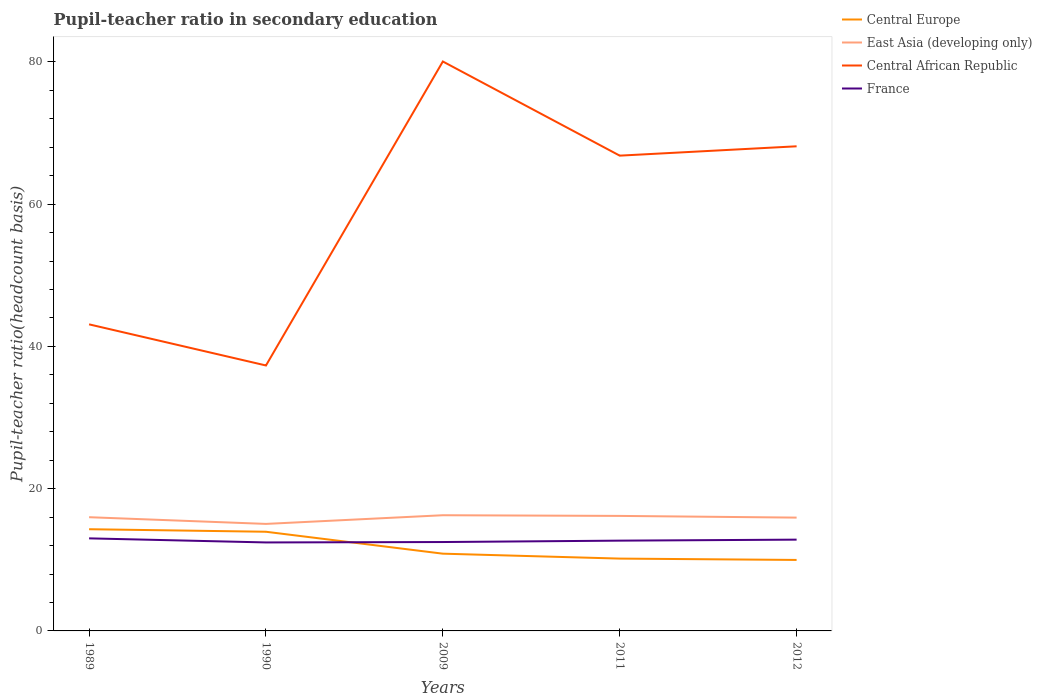How many different coloured lines are there?
Provide a succinct answer. 4. Does the line corresponding to Central Europe intersect with the line corresponding to Central African Republic?
Provide a short and direct response. No. Is the number of lines equal to the number of legend labels?
Provide a short and direct response. Yes. Across all years, what is the maximum pupil-teacher ratio in secondary education in Central Europe?
Ensure brevity in your answer.  9.98. What is the total pupil-teacher ratio in secondary education in Central Europe in the graph?
Your answer should be compact. 3.77. What is the difference between the highest and the second highest pupil-teacher ratio in secondary education in France?
Keep it short and to the point. 0.57. What is the difference between the highest and the lowest pupil-teacher ratio in secondary education in Central African Republic?
Your answer should be compact. 3. Is the pupil-teacher ratio in secondary education in Central African Republic strictly greater than the pupil-teacher ratio in secondary education in Central Europe over the years?
Offer a very short reply. No. How many lines are there?
Keep it short and to the point. 4. What is the difference between two consecutive major ticks on the Y-axis?
Offer a terse response. 20. Are the values on the major ticks of Y-axis written in scientific E-notation?
Your answer should be very brief. No. Does the graph contain grids?
Provide a succinct answer. No. Where does the legend appear in the graph?
Provide a succinct answer. Top right. What is the title of the graph?
Your answer should be very brief. Pupil-teacher ratio in secondary education. Does "Comoros" appear as one of the legend labels in the graph?
Provide a succinct answer. No. What is the label or title of the Y-axis?
Give a very brief answer. Pupil-teacher ratio(headcount basis). What is the Pupil-teacher ratio(headcount basis) of Central Europe in 1989?
Ensure brevity in your answer.  14.3. What is the Pupil-teacher ratio(headcount basis) of East Asia (developing only) in 1989?
Make the answer very short. 15.99. What is the Pupil-teacher ratio(headcount basis) of Central African Republic in 1989?
Provide a short and direct response. 43.1. What is the Pupil-teacher ratio(headcount basis) of France in 1989?
Your response must be concise. 13.01. What is the Pupil-teacher ratio(headcount basis) in Central Europe in 1990?
Provide a succinct answer. 13.94. What is the Pupil-teacher ratio(headcount basis) in East Asia (developing only) in 1990?
Offer a terse response. 15.04. What is the Pupil-teacher ratio(headcount basis) of Central African Republic in 1990?
Give a very brief answer. 37.32. What is the Pupil-teacher ratio(headcount basis) in France in 1990?
Give a very brief answer. 12.44. What is the Pupil-teacher ratio(headcount basis) of Central Europe in 2009?
Provide a succinct answer. 10.86. What is the Pupil-teacher ratio(headcount basis) of East Asia (developing only) in 2009?
Ensure brevity in your answer.  16.26. What is the Pupil-teacher ratio(headcount basis) in Central African Republic in 2009?
Your response must be concise. 80.05. What is the Pupil-teacher ratio(headcount basis) of France in 2009?
Keep it short and to the point. 12.5. What is the Pupil-teacher ratio(headcount basis) in Central Europe in 2011?
Your answer should be very brief. 10.17. What is the Pupil-teacher ratio(headcount basis) in East Asia (developing only) in 2011?
Offer a very short reply. 16.17. What is the Pupil-teacher ratio(headcount basis) in Central African Republic in 2011?
Keep it short and to the point. 66.82. What is the Pupil-teacher ratio(headcount basis) of France in 2011?
Provide a succinct answer. 12.69. What is the Pupil-teacher ratio(headcount basis) of Central Europe in 2012?
Make the answer very short. 9.98. What is the Pupil-teacher ratio(headcount basis) of East Asia (developing only) in 2012?
Provide a succinct answer. 15.93. What is the Pupil-teacher ratio(headcount basis) of Central African Republic in 2012?
Give a very brief answer. 68.13. What is the Pupil-teacher ratio(headcount basis) in France in 2012?
Ensure brevity in your answer.  12.83. Across all years, what is the maximum Pupil-teacher ratio(headcount basis) in Central Europe?
Your response must be concise. 14.3. Across all years, what is the maximum Pupil-teacher ratio(headcount basis) in East Asia (developing only)?
Your answer should be very brief. 16.26. Across all years, what is the maximum Pupil-teacher ratio(headcount basis) in Central African Republic?
Provide a succinct answer. 80.05. Across all years, what is the maximum Pupil-teacher ratio(headcount basis) in France?
Ensure brevity in your answer.  13.01. Across all years, what is the minimum Pupil-teacher ratio(headcount basis) of Central Europe?
Offer a very short reply. 9.98. Across all years, what is the minimum Pupil-teacher ratio(headcount basis) of East Asia (developing only)?
Your answer should be compact. 15.04. Across all years, what is the minimum Pupil-teacher ratio(headcount basis) of Central African Republic?
Your answer should be compact. 37.32. Across all years, what is the minimum Pupil-teacher ratio(headcount basis) of France?
Offer a very short reply. 12.44. What is the total Pupil-teacher ratio(headcount basis) in Central Europe in the graph?
Offer a terse response. 59.24. What is the total Pupil-teacher ratio(headcount basis) in East Asia (developing only) in the graph?
Keep it short and to the point. 79.39. What is the total Pupil-teacher ratio(headcount basis) in Central African Republic in the graph?
Make the answer very short. 295.42. What is the total Pupil-teacher ratio(headcount basis) of France in the graph?
Provide a short and direct response. 63.47. What is the difference between the Pupil-teacher ratio(headcount basis) in Central Europe in 1989 and that in 1990?
Offer a very short reply. 0.36. What is the difference between the Pupil-teacher ratio(headcount basis) in East Asia (developing only) in 1989 and that in 1990?
Your answer should be very brief. 0.94. What is the difference between the Pupil-teacher ratio(headcount basis) of Central African Republic in 1989 and that in 1990?
Provide a succinct answer. 5.78. What is the difference between the Pupil-teacher ratio(headcount basis) in France in 1989 and that in 1990?
Provide a short and direct response. 0.57. What is the difference between the Pupil-teacher ratio(headcount basis) of Central Europe in 1989 and that in 2009?
Your answer should be compact. 3.44. What is the difference between the Pupil-teacher ratio(headcount basis) in East Asia (developing only) in 1989 and that in 2009?
Give a very brief answer. -0.28. What is the difference between the Pupil-teacher ratio(headcount basis) of Central African Republic in 1989 and that in 2009?
Keep it short and to the point. -36.95. What is the difference between the Pupil-teacher ratio(headcount basis) of France in 1989 and that in 2009?
Keep it short and to the point. 0.52. What is the difference between the Pupil-teacher ratio(headcount basis) in Central Europe in 1989 and that in 2011?
Your answer should be very brief. 4.13. What is the difference between the Pupil-teacher ratio(headcount basis) of East Asia (developing only) in 1989 and that in 2011?
Provide a short and direct response. -0.18. What is the difference between the Pupil-teacher ratio(headcount basis) of Central African Republic in 1989 and that in 2011?
Provide a succinct answer. -23.72. What is the difference between the Pupil-teacher ratio(headcount basis) in France in 1989 and that in 2011?
Your response must be concise. 0.32. What is the difference between the Pupil-teacher ratio(headcount basis) in Central Europe in 1989 and that in 2012?
Provide a short and direct response. 4.32. What is the difference between the Pupil-teacher ratio(headcount basis) of East Asia (developing only) in 1989 and that in 2012?
Your response must be concise. 0.06. What is the difference between the Pupil-teacher ratio(headcount basis) in Central African Republic in 1989 and that in 2012?
Your answer should be very brief. -25.03. What is the difference between the Pupil-teacher ratio(headcount basis) of France in 1989 and that in 2012?
Provide a short and direct response. 0.18. What is the difference between the Pupil-teacher ratio(headcount basis) in Central Europe in 1990 and that in 2009?
Give a very brief answer. 3.08. What is the difference between the Pupil-teacher ratio(headcount basis) of East Asia (developing only) in 1990 and that in 2009?
Your response must be concise. -1.22. What is the difference between the Pupil-teacher ratio(headcount basis) in Central African Republic in 1990 and that in 2009?
Make the answer very short. -42.73. What is the difference between the Pupil-teacher ratio(headcount basis) of France in 1990 and that in 2009?
Provide a short and direct response. -0.06. What is the difference between the Pupil-teacher ratio(headcount basis) of Central Europe in 1990 and that in 2011?
Offer a terse response. 3.77. What is the difference between the Pupil-teacher ratio(headcount basis) of East Asia (developing only) in 1990 and that in 2011?
Provide a short and direct response. -1.12. What is the difference between the Pupil-teacher ratio(headcount basis) in Central African Republic in 1990 and that in 2011?
Ensure brevity in your answer.  -29.5. What is the difference between the Pupil-teacher ratio(headcount basis) in France in 1990 and that in 2011?
Ensure brevity in your answer.  -0.25. What is the difference between the Pupil-teacher ratio(headcount basis) in Central Europe in 1990 and that in 2012?
Provide a succinct answer. 3.96. What is the difference between the Pupil-teacher ratio(headcount basis) of East Asia (developing only) in 1990 and that in 2012?
Your response must be concise. -0.88. What is the difference between the Pupil-teacher ratio(headcount basis) in Central African Republic in 1990 and that in 2012?
Offer a terse response. -30.81. What is the difference between the Pupil-teacher ratio(headcount basis) of France in 1990 and that in 2012?
Ensure brevity in your answer.  -0.39. What is the difference between the Pupil-teacher ratio(headcount basis) of Central Europe in 2009 and that in 2011?
Keep it short and to the point. 0.69. What is the difference between the Pupil-teacher ratio(headcount basis) in East Asia (developing only) in 2009 and that in 2011?
Offer a terse response. 0.1. What is the difference between the Pupil-teacher ratio(headcount basis) of Central African Republic in 2009 and that in 2011?
Provide a succinct answer. 13.24. What is the difference between the Pupil-teacher ratio(headcount basis) in France in 2009 and that in 2011?
Give a very brief answer. -0.19. What is the difference between the Pupil-teacher ratio(headcount basis) in Central Europe in 2009 and that in 2012?
Your response must be concise. 0.88. What is the difference between the Pupil-teacher ratio(headcount basis) in East Asia (developing only) in 2009 and that in 2012?
Your response must be concise. 0.34. What is the difference between the Pupil-teacher ratio(headcount basis) in Central African Republic in 2009 and that in 2012?
Make the answer very short. 11.92. What is the difference between the Pupil-teacher ratio(headcount basis) of France in 2009 and that in 2012?
Provide a short and direct response. -0.34. What is the difference between the Pupil-teacher ratio(headcount basis) in Central Europe in 2011 and that in 2012?
Make the answer very short. 0.19. What is the difference between the Pupil-teacher ratio(headcount basis) in East Asia (developing only) in 2011 and that in 2012?
Keep it short and to the point. 0.24. What is the difference between the Pupil-teacher ratio(headcount basis) in Central African Republic in 2011 and that in 2012?
Offer a terse response. -1.31. What is the difference between the Pupil-teacher ratio(headcount basis) of France in 2011 and that in 2012?
Your response must be concise. -0.14. What is the difference between the Pupil-teacher ratio(headcount basis) in Central Europe in 1989 and the Pupil-teacher ratio(headcount basis) in East Asia (developing only) in 1990?
Your answer should be compact. -0.75. What is the difference between the Pupil-teacher ratio(headcount basis) of Central Europe in 1989 and the Pupil-teacher ratio(headcount basis) of Central African Republic in 1990?
Give a very brief answer. -23.02. What is the difference between the Pupil-teacher ratio(headcount basis) in Central Europe in 1989 and the Pupil-teacher ratio(headcount basis) in France in 1990?
Keep it short and to the point. 1.86. What is the difference between the Pupil-teacher ratio(headcount basis) in East Asia (developing only) in 1989 and the Pupil-teacher ratio(headcount basis) in Central African Republic in 1990?
Provide a short and direct response. -21.33. What is the difference between the Pupil-teacher ratio(headcount basis) in East Asia (developing only) in 1989 and the Pupil-teacher ratio(headcount basis) in France in 1990?
Provide a succinct answer. 3.55. What is the difference between the Pupil-teacher ratio(headcount basis) of Central African Republic in 1989 and the Pupil-teacher ratio(headcount basis) of France in 1990?
Provide a succinct answer. 30.66. What is the difference between the Pupil-teacher ratio(headcount basis) in Central Europe in 1989 and the Pupil-teacher ratio(headcount basis) in East Asia (developing only) in 2009?
Offer a terse response. -1.97. What is the difference between the Pupil-teacher ratio(headcount basis) of Central Europe in 1989 and the Pupil-teacher ratio(headcount basis) of Central African Republic in 2009?
Offer a terse response. -65.76. What is the difference between the Pupil-teacher ratio(headcount basis) in Central Europe in 1989 and the Pupil-teacher ratio(headcount basis) in France in 2009?
Ensure brevity in your answer.  1.8. What is the difference between the Pupil-teacher ratio(headcount basis) of East Asia (developing only) in 1989 and the Pupil-teacher ratio(headcount basis) of Central African Republic in 2009?
Your response must be concise. -64.06. What is the difference between the Pupil-teacher ratio(headcount basis) of East Asia (developing only) in 1989 and the Pupil-teacher ratio(headcount basis) of France in 2009?
Your answer should be compact. 3.49. What is the difference between the Pupil-teacher ratio(headcount basis) of Central African Republic in 1989 and the Pupil-teacher ratio(headcount basis) of France in 2009?
Make the answer very short. 30.6. What is the difference between the Pupil-teacher ratio(headcount basis) in Central Europe in 1989 and the Pupil-teacher ratio(headcount basis) in East Asia (developing only) in 2011?
Offer a terse response. -1.87. What is the difference between the Pupil-teacher ratio(headcount basis) of Central Europe in 1989 and the Pupil-teacher ratio(headcount basis) of Central African Republic in 2011?
Offer a very short reply. -52.52. What is the difference between the Pupil-teacher ratio(headcount basis) in Central Europe in 1989 and the Pupil-teacher ratio(headcount basis) in France in 2011?
Offer a terse response. 1.61. What is the difference between the Pupil-teacher ratio(headcount basis) in East Asia (developing only) in 1989 and the Pupil-teacher ratio(headcount basis) in Central African Republic in 2011?
Offer a terse response. -50.83. What is the difference between the Pupil-teacher ratio(headcount basis) in East Asia (developing only) in 1989 and the Pupil-teacher ratio(headcount basis) in France in 2011?
Your answer should be very brief. 3.3. What is the difference between the Pupil-teacher ratio(headcount basis) of Central African Republic in 1989 and the Pupil-teacher ratio(headcount basis) of France in 2011?
Offer a very short reply. 30.41. What is the difference between the Pupil-teacher ratio(headcount basis) of Central Europe in 1989 and the Pupil-teacher ratio(headcount basis) of East Asia (developing only) in 2012?
Give a very brief answer. -1.63. What is the difference between the Pupil-teacher ratio(headcount basis) of Central Europe in 1989 and the Pupil-teacher ratio(headcount basis) of Central African Republic in 2012?
Keep it short and to the point. -53.83. What is the difference between the Pupil-teacher ratio(headcount basis) of Central Europe in 1989 and the Pupil-teacher ratio(headcount basis) of France in 2012?
Keep it short and to the point. 1.46. What is the difference between the Pupil-teacher ratio(headcount basis) of East Asia (developing only) in 1989 and the Pupil-teacher ratio(headcount basis) of Central African Republic in 2012?
Your response must be concise. -52.14. What is the difference between the Pupil-teacher ratio(headcount basis) of East Asia (developing only) in 1989 and the Pupil-teacher ratio(headcount basis) of France in 2012?
Ensure brevity in your answer.  3.15. What is the difference between the Pupil-teacher ratio(headcount basis) in Central African Republic in 1989 and the Pupil-teacher ratio(headcount basis) in France in 2012?
Keep it short and to the point. 30.27. What is the difference between the Pupil-teacher ratio(headcount basis) of Central Europe in 1990 and the Pupil-teacher ratio(headcount basis) of East Asia (developing only) in 2009?
Provide a succinct answer. -2.32. What is the difference between the Pupil-teacher ratio(headcount basis) of Central Europe in 1990 and the Pupil-teacher ratio(headcount basis) of Central African Republic in 2009?
Offer a terse response. -66.11. What is the difference between the Pupil-teacher ratio(headcount basis) in Central Europe in 1990 and the Pupil-teacher ratio(headcount basis) in France in 2009?
Make the answer very short. 1.45. What is the difference between the Pupil-teacher ratio(headcount basis) of East Asia (developing only) in 1990 and the Pupil-teacher ratio(headcount basis) of Central African Republic in 2009?
Offer a very short reply. -65.01. What is the difference between the Pupil-teacher ratio(headcount basis) in East Asia (developing only) in 1990 and the Pupil-teacher ratio(headcount basis) in France in 2009?
Offer a very short reply. 2.55. What is the difference between the Pupil-teacher ratio(headcount basis) in Central African Republic in 1990 and the Pupil-teacher ratio(headcount basis) in France in 2009?
Ensure brevity in your answer.  24.82. What is the difference between the Pupil-teacher ratio(headcount basis) of Central Europe in 1990 and the Pupil-teacher ratio(headcount basis) of East Asia (developing only) in 2011?
Your answer should be compact. -2.23. What is the difference between the Pupil-teacher ratio(headcount basis) in Central Europe in 1990 and the Pupil-teacher ratio(headcount basis) in Central African Republic in 2011?
Your response must be concise. -52.88. What is the difference between the Pupil-teacher ratio(headcount basis) of Central Europe in 1990 and the Pupil-teacher ratio(headcount basis) of France in 2011?
Your answer should be very brief. 1.25. What is the difference between the Pupil-teacher ratio(headcount basis) in East Asia (developing only) in 1990 and the Pupil-teacher ratio(headcount basis) in Central African Republic in 2011?
Make the answer very short. -51.77. What is the difference between the Pupil-teacher ratio(headcount basis) of East Asia (developing only) in 1990 and the Pupil-teacher ratio(headcount basis) of France in 2011?
Your answer should be very brief. 2.35. What is the difference between the Pupil-teacher ratio(headcount basis) of Central African Republic in 1990 and the Pupil-teacher ratio(headcount basis) of France in 2011?
Give a very brief answer. 24.63. What is the difference between the Pupil-teacher ratio(headcount basis) of Central Europe in 1990 and the Pupil-teacher ratio(headcount basis) of East Asia (developing only) in 2012?
Offer a very short reply. -1.99. What is the difference between the Pupil-teacher ratio(headcount basis) of Central Europe in 1990 and the Pupil-teacher ratio(headcount basis) of Central African Republic in 2012?
Your response must be concise. -54.19. What is the difference between the Pupil-teacher ratio(headcount basis) in Central Europe in 1990 and the Pupil-teacher ratio(headcount basis) in France in 2012?
Your response must be concise. 1.11. What is the difference between the Pupil-teacher ratio(headcount basis) of East Asia (developing only) in 1990 and the Pupil-teacher ratio(headcount basis) of Central African Republic in 2012?
Provide a succinct answer. -53.09. What is the difference between the Pupil-teacher ratio(headcount basis) in East Asia (developing only) in 1990 and the Pupil-teacher ratio(headcount basis) in France in 2012?
Your answer should be compact. 2.21. What is the difference between the Pupil-teacher ratio(headcount basis) in Central African Republic in 1990 and the Pupil-teacher ratio(headcount basis) in France in 2012?
Provide a short and direct response. 24.48. What is the difference between the Pupil-teacher ratio(headcount basis) of Central Europe in 2009 and the Pupil-teacher ratio(headcount basis) of East Asia (developing only) in 2011?
Make the answer very short. -5.31. What is the difference between the Pupil-teacher ratio(headcount basis) of Central Europe in 2009 and the Pupil-teacher ratio(headcount basis) of Central African Republic in 2011?
Give a very brief answer. -55.96. What is the difference between the Pupil-teacher ratio(headcount basis) in Central Europe in 2009 and the Pupil-teacher ratio(headcount basis) in France in 2011?
Keep it short and to the point. -1.83. What is the difference between the Pupil-teacher ratio(headcount basis) of East Asia (developing only) in 2009 and the Pupil-teacher ratio(headcount basis) of Central African Republic in 2011?
Offer a very short reply. -50.55. What is the difference between the Pupil-teacher ratio(headcount basis) of East Asia (developing only) in 2009 and the Pupil-teacher ratio(headcount basis) of France in 2011?
Make the answer very short. 3.57. What is the difference between the Pupil-teacher ratio(headcount basis) in Central African Republic in 2009 and the Pupil-teacher ratio(headcount basis) in France in 2011?
Keep it short and to the point. 67.36. What is the difference between the Pupil-teacher ratio(headcount basis) of Central Europe in 2009 and the Pupil-teacher ratio(headcount basis) of East Asia (developing only) in 2012?
Provide a short and direct response. -5.07. What is the difference between the Pupil-teacher ratio(headcount basis) of Central Europe in 2009 and the Pupil-teacher ratio(headcount basis) of Central African Republic in 2012?
Ensure brevity in your answer.  -57.27. What is the difference between the Pupil-teacher ratio(headcount basis) of Central Europe in 2009 and the Pupil-teacher ratio(headcount basis) of France in 2012?
Make the answer very short. -1.97. What is the difference between the Pupil-teacher ratio(headcount basis) in East Asia (developing only) in 2009 and the Pupil-teacher ratio(headcount basis) in Central African Republic in 2012?
Your answer should be very brief. -51.87. What is the difference between the Pupil-teacher ratio(headcount basis) of East Asia (developing only) in 2009 and the Pupil-teacher ratio(headcount basis) of France in 2012?
Make the answer very short. 3.43. What is the difference between the Pupil-teacher ratio(headcount basis) in Central African Republic in 2009 and the Pupil-teacher ratio(headcount basis) in France in 2012?
Your response must be concise. 67.22. What is the difference between the Pupil-teacher ratio(headcount basis) of Central Europe in 2011 and the Pupil-teacher ratio(headcount basis) of East Asia (developing only) in 2012?
Your answer should be very brief. -5.76. What is the difference between the Pupil-teacher ratio(headcount basis) of Central Europe in 2011 and the Pupil-teacher ratio(headcount basis) of Central African Republic in 2012?
Offer a very short reply. -57.96. What is the difference between the Pupil-teacher ratio(headcount basis) of Central Europe in 2011 and the Pupil-teacher ratio(headcount basis) of France in 2012?
Provide a succinct answer. -2.67. What is the difference between the Pupil-teacher ratio(headcount basis) of East Asia (developing only) in 2011 and the Pupil-teacher ratio(headcount basis) of Central African Republic in 2012?
Provide a short and direct response. -51.96. What is the difference between the Pupil-teacher ratio(headcount basis) of East Asia (developing only) in 2011 and the Pupil-teacher ratio(headcount basis) of France in 2012?
Offer a very short reply. 3.34. What is the difference between the Pupil-teacher ratio(headcount basis) in Central African Republic in 2011 and the Pupil-teacher ratio(headcount basis) in France in 2012?
Your answer should be compact. 53.98. What is the average Pupil-teacher ratio(headcount basis) in Central Europe per year?
Give a very brief answer. 11.85. What is the average Pupil-teacher ratio(headcount basis) in East Asia (developing only) per year?
Offer a very short reply. 15.88. What is the average Pupil-teacher ratio(headcount basis) of Central African Republic per year?
Offer a very short reply. 59.08. What is the average Pupil-teacher ratio(headcount basis) of France per year?
Make the answer very short. 12.69. In the year 1989, what is the difference between the Pupil-teacher ratio(headcount basis) of Central Europe and Pupil-teacher ratio(headcount basis) of East Asia (developing only)?
Give a very brief answer. -1.69. In the year 1989, what is the difference between the Pupil-teacher ratio(headcount basis) of Central Europe and Pupil-teacher ratio(headcount basis) of Central African Republic?
Ensure brevity in your answer.  -28.8. In the year 1989, what is the difference between the Pupil-teacher ratio(headcount basis) of Central Europe and Pupil-teacher ratio(headcount basis) of France?
Your answer should be compact. 1.28. In the year 1989, what is the difference between the Pupil-teacher ratio(headcount basis) in East Asia (developing only) and Pupil-teacher ratio(headcount basis) in Central African Republic?
Provide a succinct answer. -27.11. In the year 1989, what is the difference between the Pupil-teacher ratio(headcount basis) of East Asia (developing only) and Pupil-teacher ratio(headcount basis) of France?
Offer a very short reply. 2.98. In the year 1989, what is the difference between the Pupil-teacher ratio(headcount basis) in Central African Republic and Pupil-teacher ratio(headcount basis) in France?
Give a very brief answer. 30.09. In the year 1990, what is the difference between the Pupil-teacher ratio(headcount basis) of Central Europe and Pupil-teacher ratio(headcount basis) of East Asia (developing only)?
Make the answer very short. -1.1. In the year 1990, what is the difference between the Pupil-teacher ratio(headcount basis) of Central Europe and Pupil-teacher ratio(headcount basis) of Central African Republic?
Provide a short and direct response. -23.38. In the year 1990, what is the difference between the Pupil-teacher ratio(headcount basis) of Central Europe and Pupil-teacher ratio(headcount basis) of France?
Make the answer very short. 1.5. In the year 1990, what is the difference between the Pupil-teacher ratio(headcount basis) of East Asia (developing only) and Pupil-teacher ratio(headcount basis) of Central African Republic?
Give a very brief answer. -22.27. In the year 1990, what is the difference between the Pupil-teacher ratio(headcount basis) of East Asia (developing only) and Pupil-teacher ratio(headcount basis) of France?
Give a very brief answer. 2.61. In the year 1990, what is the difference between the Pupil-teacher ratio(headcount basis) of Central African Republic and Pupil-teacher ratio(headcount basis) of France?
Give a very brief answer. 24.88. In the year 2009, what is the difference between the Pupil-teacher ratio(headcount basis) of Central Europe and Pupil-teacher ratio(headcount basis) of East Asia (developing only)?
Your answer should be very brief. -5.4. In the year 2009, what is the difference between the Pupil-teacher ratio(headcount basis) in Central Europe and Pupil-teacher ratio(headcount basis) in Central African Republic?
Your answer should be compact. -69.19. In the year 2009, what is the difference between the Pupil-teacher ratio(headcount basis) in Central Europe and Pupil-teacher ratio(headcount basis) in France?
Ensure brevity in your answer.  -1.64. In the year 2009, what is the difference between the Pupil-teacher ratio(headcount basis) of East Asia (developing only) and Pupil-teacher ratio(headcount basis) of Central African Republic?
Ensure brevity in your answer.  -63.79. In the year 2009, what is the difference between the Pupil-teacher ratio(headcount basis) in East Asia (developing only) and Pupil-teacher ratio(headcount basis) in France?
Ensure brevity in your answer.  3.77. In the year 2009, what is the difference between the Pupil-teacher ratio(headcount basis) of Central African Republic and Pupil-teacher ratio(headcount basis) of France?
Your answer should be very brief. 67.56. In the year 2011, what is the difference between the Pupil-teacher ratio(headcount basis) in Central Europe and Pupil-teacher ratio(headcount basis) in East Asia (developing only)?
Give a very brief answer. -6. In the year 2011, what is the difference between the Pupil-teacher ratio(headcount basis) in Central Europe and Pupil-teacher ratio(headcount basis) in Central African Republic?
Offer a very short reply. -56.65. In the year 2011, what is the difference between the Pupil-teacher ratio(headcount basis) in Central Europe and Pupil-teacher ratio(headcount basis) in France?
Offer a very short reply. -2.52. In the year 2011, what is the difference between the Pupil-teacher ratio(headcount basis) in East Asia (developing only) and Pupil-teacher ratio(headcount basis) in Central African Republic?
Offer a terse response. -50.65. In the year 2011, what is the difference between the Pupil-teacher ratio(headcount basis) of East Asia (developing only) and Pupil-teacher ratio(headcount basis) of France?
Make the answer very short. 3.48. In the year 2011, what is the difference between the Pupil-teacher ratio(headcount basis) of Central African Republic and Pupil-teacher ratio(headcount basis) of France?
Give a very brief answer. 54.13. In the year 2012, what is the difference between the Pupil-teacher ratio(headcount basis) of Central Europe and Pupil-teacher ratio(headcount basis) of East Asia (developing only)?
Offer a very short reply. -5.95. In the year 2012, what is the difference between the Pupil-teacher ratio(headcount basis) in Central Europe and Pupil-teacher ratio(headcount basis) in Central African Republic?
Give a very brief answer. -58.15. In the year 2012, what is the difference between the Pupil-teacher ratio(headcount basis) of Central Europe and Pupil-teacher ratio(headcount basis) of France?
Keep it short and to the point. -2.85. In the year 2012, what is the difference between the Pupil-teacher ratio(headcount basis) in East Asia (developing only) and Pupil-teacher ratio(headcount basis) in Central African Republic?
Make the answer very short. -52.2. In the year 2012, what is the difference between the Pupil-teacher ratio(headcount basis) of East Asia (developing only) and Pupil-teacher ratio(headcount basis) of France?
Offer a very short reply. 3.1. In the year 2012, what is the difference between the Pupil-teacher ratio(headcount basis) in Central African Republic and Pupil-teacher ratio(headcount basis) in France?
Provide a succinct answer. 55.3. What is the ratio of the Pupil-teacher ratio(headcount basis) in Central Europe in 1989 to that in 1990?
Keep it short and to the point. 1.03. What is the ratio of the Pupil-teacher ratio(headcount basis) in East Asia (developing only) in 1989 to that in 1990?
Keep it short and to the point. 1.06. What is the ratio of the Pupil-teacher ratio(headcount basis) of Central African Republic in 1989 to that in 1990?
Your answer should be compact. 1.15. What is the ratio of the Pupil-teacher ratio(headcount basis) of France in 1989 to that in 1990?
Offer a very short reply. 1.05. What is the ratio of the Pupil-teacher ratio(headcount basis) in Central Europe in 1989 to that in 2009?
Ensure brevity in your answer.  1.32. What is the ratio of the Pupil-teacher ratio(headcount basis) of Central African Republic in 1989 to that in 2009?
Give a very brief answer. 0.54. What is the ratio of the Pupil-teacher ratio(headcount basis) in France in 1989 to that in 2009?
Provide a succinct answer. 1.04. What is the ratio of the Pupil-teacher ratio(headcount basis) in Central Europe in 1989 to that in 2011?
Make the answer very short. 1.41. What is the ratio of the Pupil-teacher ratio(headcount basis) of Central African Republic in 1989 to that in 2011?
Give a very brief answer. 0.65. What is the ratio of the Pupil-teacher ratio(headcount basis) of France in 1989 to that in 2011?
Offer a terse response. 1.03. What is the ratio of the Pupil-teacher ratio(headcount basis) in Central Europe in 1989 to that in 2012?
Your answer should be very brief. 1.43. What is the ratio of the Pupil-teacher ratio(headcount basis) in Central African Republic in 1989 to that in 2012?
Your answer should be compact. 0.63. What is the ratio of the Pupil-teacher ratio(headcount basis) in Central Europe in 1990 to that in 2009?
Keep it short and to the point. 1.28. What is the ratio of the Pupil-teacher ratio(headcount basis) of East Asia (developing only) in 1990 to that in 2009?
Keep it short and to the point. 0.93. What is the ratio of the Pupil-teacher ratio(headcount basis) of Central African Republic in 1990 to that in 2009?
Make the answer very short. 0.47. What is the ratio of the Pupil-teacher ratio(headcount basis) of France in 1990 to that in 2009?
Keep it short and to the point. 1. What is the ratio of the Pupil-teacher ratio(headcount basis) in Central Europe in 1990 to that in 2011?
Make the answer very short. 1.37. What is the ratio of the Pupil-teacher ratio(headcount basis) of East Asia (developing only) in 1990 to that in 2011?
Your answer should be compact. 0.93. What is the ratio of the Pupil-teacher ratio(headcount basis) of Central African Republic in 1990 to that in 2011?
Ensure brevity in your answer.  0.56. What is the ratio of the Pupil-teacher ratio(headcount basis) of France in 1990 to that in 2011?
Provide a succinct answer. 0.98. What is the ratio of the Pupil-teacher ratio(headcount basis) in Central Europe in 1990 to that in 2012?
Provide a short and direct response. 1.4. What is the ratio of the Pupil-teacher ratio(headcount basis) of East Asia (developing only) in 1990 to that in 2012?
Provide a succinct answer. 0.94. What is the ratio of the Pupil-teacher ratio(headcount basis) in Central African Republic in 1990 to that in 2012?
Your response must be concise. 0.55. What is the ratio of the Pupil-teacher ratio(headcount basis) of France in 1990 to that in 2012?
Keep it short and to the point. 0.97. What is the ratio of the Pupil-teacher ratio(headcount basis) of Central Europe in 2009 to that in 2011?
Give a very brief answer. 1.07. What is the ratio of the Pupil-teacher ratio(headcount basis) in East Asia (developing only) in 2009 to that in 2011?
Your answer should be very brief. 1.01. What is the ratio of the Pupil-teacher ratio(headcount basis) in Central African Republic in 2009 to that in 2011?
Provide a succinct answer. 1.2. What is the ratio of the Pupil-teacher ratio(headcount basis) in France in 2009 to that in 2011?
Give a very brief answer. 0.98. What is the ratio of the Pupil-teacher ratio(headcount basis) of Central Europe in 2009 to that in 2012?
Your answer should be very brief. 1.09. What is the ratio of the Pupil-teacher ratio(headcount basis) in East Asia (developing only) in 2009 to that in 2012?
Offer a terse response. 1.02. What is the ratio of the Pupil-teacher ratio(headcount basis) of Central African Republic in 2009 to that in 2012?
Your response must be concise. 1.18. What is the ratio of the Pupil-teacher ratio(headcount basis) in France in 2009 to that in 2012?
Ensure brevity in your answer.  0.97. What is the ratio of the Pupil-teacher ratio(headcount basis) of Central Europe in 2011 to that in 2012?
Your answer should be very brief. 1.02. What is the ratio of the Pupil-teacher ratio(headcount basis) in East Asia (developing only) in 2011 to that in 2012?
Make the answer very short. 1.01. What is the ratio of the Pupil-teacher ratio(headcount basis) of Central African Republic in 2011 to that in 2012?
Keep it short and to the point. 0.98. What is the ratio of the Pupil-teacher ratio(headcount basis) of France in 2011 to that in 2012?
Your answer should be very brief. 0.99. What is the difference between the highest and the second highest Pupil-teacher ratio(headcount basis) in Central Europe?
Ensure brevity in your answer.  0.36. What is the difference between the highest and the second highest Pupil-teacher ratio(headcount basis) in East Asia (developing only)?
Your answer should be compact. 0.1. What is the difference between the highest and the second highest Pupil-teacher ratio(headcount basis) of Central African Republic?
Offer a very short reply. 11.92. What is the difference between the highest and the second highest Pupil-teacher ratio(headcount basis) of France?
Give a very brief answer. 0.18. What is the difference between the highest and the lowest Pupil-teacher ratio(headcount basis) of Central Europe?
Provide a succinct answer. 4.32. What is the difference between the highest and the lowest Pupil-teacher ratio(headcount basis) of East Asia (developing only)?
Your response must be concise. 1.22. What is the difference between the highest and the lowest Pupil-teacher ratio(headcount basis) of Central African Republic?
Your answer should be compact. 42.73. What is the difference between the highest and the lowest Pupil-teacher ratio(headcount basis) of France?
Ensure brevity in your answer.  0.57. 